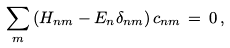Convert formula to latex. <formula><loc_0><loc_0><loc_500><loc_500>\sum _ { m } \left ( H _ { n m } - E _ { n } \delta _ { n m } \right ) c _ { n m } \, = \, 0 \, ,</formula> 